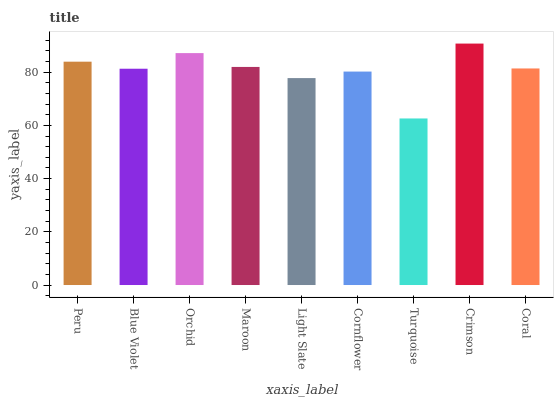Is Turquoise the minimum?
Answer yes or no. Yes. Is Crimson the maximum?
Answer yes or no. Yes. Is Blue Violet the minimum?
Answer yes or no. No. Is Blue Violet the maximum?
Answer yes or no. No. Is Peru greater than Blue Violet?
Answer yes or no. Yes. Is Blue Violet less than Peru?
Answer yes or no. Yes. Is Blue Violet greater than Peru?
Answer yes or no. No. Is Peru less than Blue Violet?
Answer yes or no. No. Is Coral the high median?
Answer yes or no. Yes. Is Coral the low median?
Answer yes or no. Yes. Is Peru the high median?
Answer yes or no. No. Is Orchid the low median?
Answer yes or no. No. 